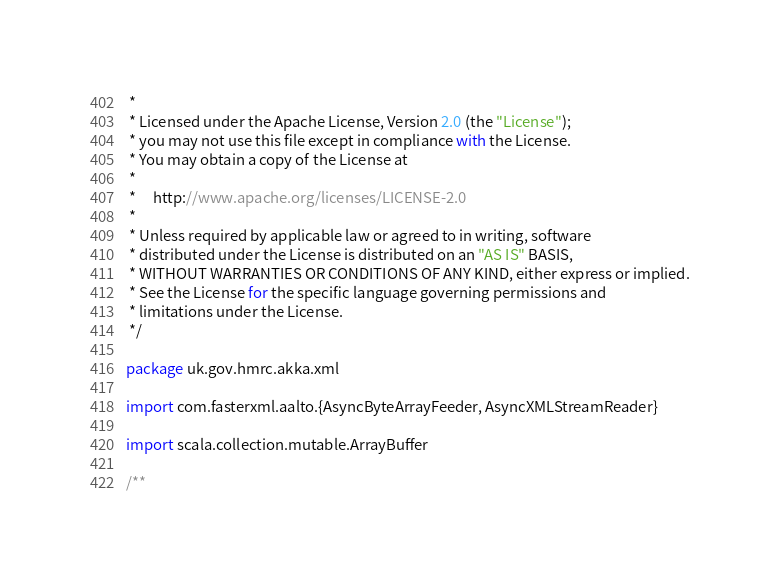<code> <loc_0><loc_0><loc_500><loc_500><_Scala_> *
 * Licensed under the Apache License, Version 2.0 (the "License");
 * you may not use this file except in compliance with the License.
 * You may obtain a copy of the License at
 *
 *     http://www.apache.org/licenses/LICENSE-2.0
 *
 * Unless required by applicable law or agreed to in writing, software
 * distributed under the License is distributed on an "AS IS" BASIS,
 * WITHOUT WARRANTIES OR CONDITIONS OF ANY KIND, either express or implied.
 * See the License for the specific language governing permissions and
 * limitations under the License.
 */

package uk.gov.hmrc.akka.xml

import com.fasterxml.aalto.{AsyncByteArrayFeeder, AsyncXMLStreamReader}

import scala.collection.mutable.ArrayBuffer

/**</code> 